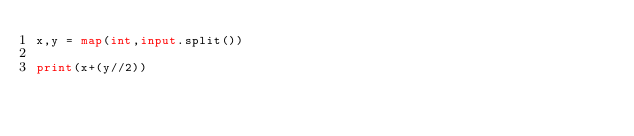<code> <loc_0><loc_0><loc_500><loc_500><_Python_>x,y = map(int,input.split())

print(x+(y//2))</code> 